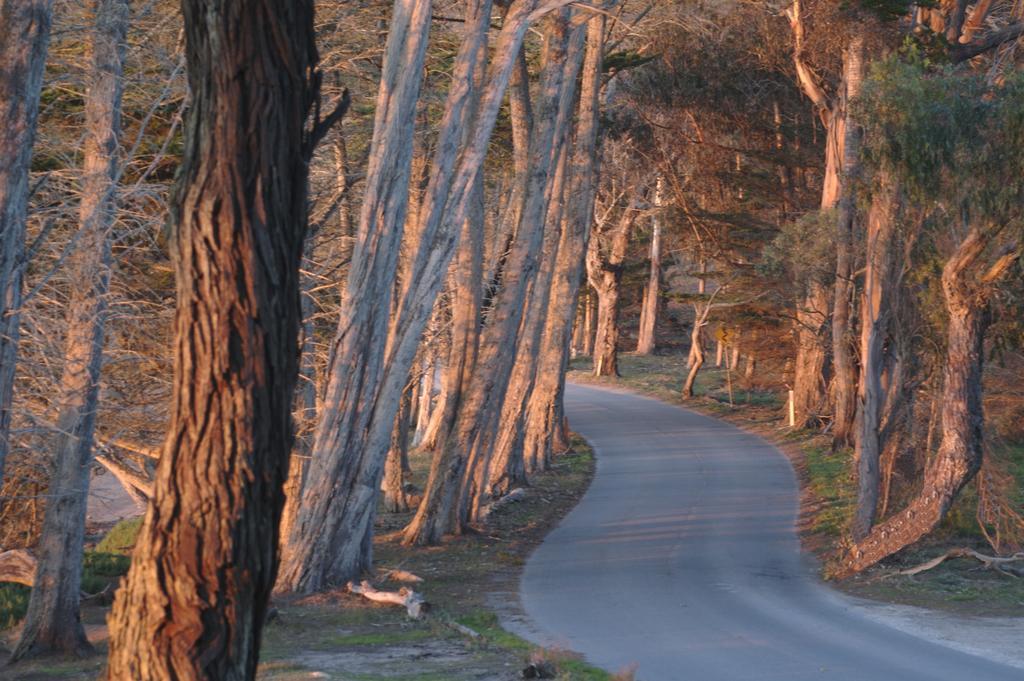In one or two sentences, can you explain what this image depicts? In this image we can see the road, grass and the trees on the either side of the image. 